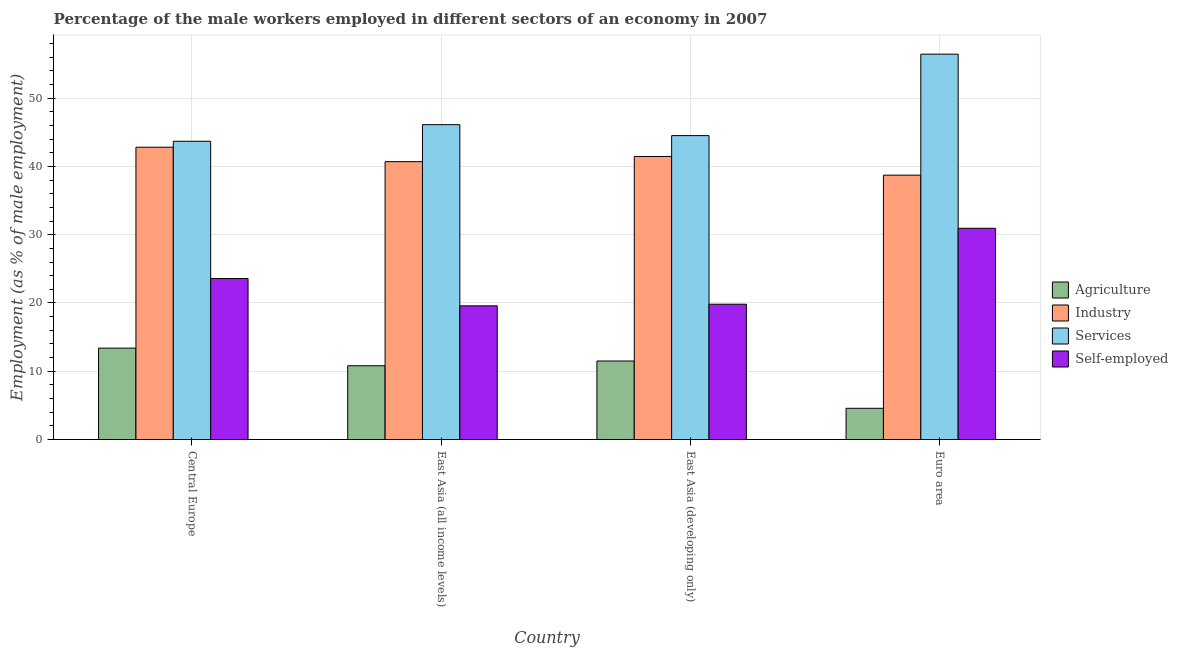How many different coloured bars are there?
Offer a terse response. 4. How many bars are there on the 1st tick from the left?
Ensure brevity in your answer.  4. How many bars are there on the 1st tick from the right?
Provide a short and direct response. 4. What is the label of the 3rd group of bars from the left?
Provide a short and direct response. East Asia (developing only). In how many cases, is the number of bars for a given country not equal to the number of legend labels?
Your response must be concise. 0. What is the percentage of self employed male workers in Central Europe?
Ensure brevity in your answer.  23.58. Across all countries, what is the maximum percentage of male workers in industry?
Keep it short and to the point. 42.82. Across all countries, what is the minimum percentage of self employed male workers?
Offer a terse response. 19.58. In which country was the percentage of male workers in agriculture maximum?
Keep it short and to the point. Central Europe. In which country was the percentage of self employed male workers minimum?
Your response must be concise. East Asia (all income levels). What is the total percentage of male workers in agriculture in the graph?
Offer a very short reply. 40.27. What is the difference between the percentage of self employed male workers in Central Europe and that in East Asia (developing only)?
Your response must be concise. 3.77. What is the difference between the percentage of self employed male workers in Euro area and the percentage of male workers in agriculture in Central Europe?
Your response must be concise. 17.55. What is the average percentage of male workers in agriculture per country?
Keep it short and to the point. 10.07. What is the difference between the percentage of male workers in industry and percentage of male workers in agriculture in Euro area?
Offer a very short reply. 34.15. In how many countries, is the percentage of male workers in services greater than 6 %?
Your answer should be compact. 4. What is the ratio of the percentage of male workers in agriculture in Central Europe to that in East Asia (developing only)?
Provide a short and direct response. 1.16. Is the percentage of male workers in industry in Central Europe less than that in Euro area?
Make the answer very short. No. What is the difference between the highest and the second highest percentage of male workers in industry?
Offer a very short reply. 1.36. What is the difference between the highest and the lowest percentage of male workers in agriculture?
Offer a terse response. 8.82. In how many countries, is the percentage of male workers in industry greater than the average percentage of male workers in industry taken over all countries?
Provide a succinct answer. 2. Is the sum of the percentage of male workers in industry in Central Europe and East Asia (developing only) greater than the maximum percentage of male workers in agriculture across all countries?
Make the answer very short. Yes. What does the 4th bar from the left in Euro area represents?
Your answer should be compact. Self-employed. What does the 1st bar from the right in East Asia (all income levels) represents?
Provide a succinct answer. Self-employed. Is it the case that in every country, the sum of the percentage of male workers in agriculture and percentage of male workers in industry is greater than the percentage of male workers in services?
Provide a short and direct response. No. How many bars are there?
Your response must be concise. 16. Are all the bars in the graph horizontal?
Provide a succinct answer. No. Are the values on the major ticks of Y-axis written in scientific E-notation?
Offer a very short reply. No. Does the graph contain any zero values?
Give a very brief answer. No. Does the graph contain grids?
Give a very brief answer. Yes. Where does the legend appear in the graph?
Your response must be concise. Center right. How many legend labels are there?
Your answer should be compact. 4. How are the legend labels stacked?
Your answer should be compact. Vertical. What is the title of the graph?
Offer a terse response. Percentage of the male workers employed in different sectors of an economy in 2007. What is the label or title of the X-axis?
Your answer should be compact. Country. What is the label or title of the Y-axis?
Provide a succinct answer. Employment (as % of male employment). What is the Employment (as % of male employment) in Agriculture in Central Europe?
Provide a short and direct response. 13.39. What is the Employment (as % of male employment) in Industry in Central Europe?
Your response must be concise. 42.82. What is the Employment (as % of male employment) in Services in Central Europe?
Keep it short and to the point. 43.68. What is the Employment (as % of male employment) of Self-employed in Central Europe?
Your answer should be very brief. 23.58. What is the Employment (as % of male employment) in Agriculture in East Asia (all income levels)?
Offer a terse response. 10.81. What is the Employment (as % of male employment) of Industry in East Asia (all income levels)?
Keep it short and to the point. 40.7. What is the Employment (as % of male employment) of Services in East Asia (all income levels)?
Your response must be concise. 46.12. What is the Employment (as % of male employment) in Self-employed in East Asia (all income levels)?
Make the answer very short. 19.58. What is the Employment (as % of male employment) in Agriculture in East Asia (developing only)?
Give a very brief answer. 11.5. What is the Employment (as % of male employment) of Industry in East Asia (developing only)?
Keep it short and to the point. 41.46. What is the Employment (as % of male employment) of Services in East Asia (developing only)?
Offer a very short reply. 44.51. What is the Employment (as % of male employment) in Self-employed in East Asia (developing only)?
Offer a terse response. 19.82. What is the Employment (as % of male employment) in Agriculture in Euro area?
Keep it short and to the point. 4.57. What is the Employment (as % of male employment) in Industry in Euro area?
Make the answer very short. 38.72. What is the Employment (as % of male employment) of Services in Euro area?
Give a very brief answer. 56.45. What is the Employment (as % of male employment) of Self-employed in Euro area?
Offer a terse response. 30.94. Across all countries, what is the maximum Employment (as % of male employment) in Agriculture?
Provide a succinct answer. 13.39. Across all countries, what is the maximum Employment (as % of male employment) of Industry?
Provide a succinct answer. 42.82. Across all countries, what is the maximum Employment (as % of male employment) in Services?
Keep it short and to the point. 56.45. Across all countries, what is the maximum Employment (as % of male employment) of Self-employed?
Your answer should be very brief. 30.94. Across all countries, what is the minimum Employment (as % of male employment) of Agriculture?
Provide a succinct answer. 4.57. Across all countries, what is the minimum Employment (as % of male employment) in Industry?
Your answer should be compact. 38.72. Across all countries, what is the minimum Employment (as % of male employment) in Services?
Provide a succinct answer. 43.68. Across all countries, what is the minimum Employment (as % of male employment) of Self-employed?
Your response must be concise. 19.58. What is the total Employment (as % of male employment) in Agriculture in the graph?
Make the answer very short. 40.27. What is the total Employment (as % of male employment) of Industry in the graph?
Make the answer very short. 163.69. What is the total Employment (as % of male employment) in Services in the graph?
Make the answer very short. 190.76. What is the total Employment (as % of male employment) in Self-employed in the graph?
Your answer should be compact. 93.92. What is the difference between the Employment (as % of male employment) in Agriculture in Central Europe and that in East Asia (all income levels)?
Your response must be concise. 2.58. What is the difference between the Employment (as % of male employment) of Industry in Central Europe and that in East Asia (all income levels)?
Provide a succinct answer. 2.12. What is the difference between the Employment (as % of male employment) of Services in Central Europe and that in East Asia (all income levels)?
Provide a short and direct response. -2.43. What is the difference between the Employment (as % of male employment) in Self-employed in Central Europe and that in East Asia (all income levels)?
Provide a short and direct response. 4.01. What is the difference between the Employment (as % of male employment) in Agriculture in Central Europe and that in East Asia (developing only)?
Ensure brevity in your answer.  1.89. What is the difference between the Employment (as % of male employment) of Industry in Central Europe and that in East Asia (developing only)?
Offer a very short reply. 1.36. What is the difference between the Employment (as % of male employment) in Services in Central Europe and that in East Asia (developing only)?
Offer a very short reply. -0.83. What is the difference between the Employment (as % of male employment) of Self-employed in Central Europe and that in East Asia (developing only)?
Your answer should be compact. 3.77. What is the difference between the Employment (as % of male employment) of Agriculture in Central Europe and that in Euro area?
Give a very brief answer. 8.82. What is the difference between the Employment (as % of male employment) in Industry in Central Europe and that in Euro area?
Offer a very short reply. 4.09. What is the difference between the Employment (as % of male employment) of Services in Central Europe and that in Euro area?
Give a very brief answer. -12.76. What is the difference between the Employment (as % of male employment) in Self-employed in Central Europe and that in Euro area?
Ensure brevity in your answer.  -7.36. What is the difference between the Employment (as % of male employment) of Agriculture in East Asia (all income levels) and that in East Asia (developing only)?
Make the answer very short. -0.69. What is the difference between the Employment (as % of male employment) in Industry in East Asia (all income levels) and that in East Asia (developing only)?
Your answer should be compact. -0.76. What is the difference between the Employment (as % of male employment) of Services in East Asia (all income levels) and that in East Asia (developing only)?
Your response must be concise. 1.61. What is the difference between the Employment (as % of male employment) of Self-employed in East Asia (all income levels) and that in East Asia (developing only)?
Your answer should be very brief. -0.24. What is the difference between the Employment (as % of male employment) of Agriculture in East Asia (all income levels) and that in Euro area?
Give a very brief answer. 6.24. What is the difference between the Employment (as % of male employment) of Industry in East Asia (all income levels) and that in Euro area?
Keep it short and to the point. 1.98. What is the difference between the Employment (as % of male employment) in Services in East Asia (all income levels) and that in Euro area?
Your response must be concise. -10.33. What is the difference between the Employment (as % of male employment) of Self-employed in East Asia (all income levels) and that in Euro area?
Your answer should be very brief. -11.36. What is the difference between the Employment (as % of male employment) in Agriculture in East Asia (developing only) and that in Euro area?
Provide a succinct answer. 6.93. What is the difference between the Employment (as % of male employment) of Industry in East Asia (developing only) and that in Euro area?
Your answer should be very brief. 2.74. What is the difference between the Employment (as % of male employment) in Services in East Asia (developing only) and that in Euro area?
Offer a terse response. -11.93. What is the difference between the Employment (as % of male employment) of Self-employed in East Asia (developing only) and that in Euro area?
Your answer should be compact. -11.13. What is the difference between the Employment (as % of male employment) of Agriculture in Central Europe and the Employment (as % of male employment) of Industry in East Asia (all income levels)?
Keep it short and to the point. -27.31. What is the difference between the Employment (as % of male employment) of Agriculture in Central Europe and the Employment (as % of male employment) of Services in East Asia (all income levels)?
Offer a very short reply. -32.73. What is the difference between the Employment (as % of male employment) in Agriculture in Central Europe and the Employment (as % of male employment) in Self-employed in East Asia (all income levels)?
Ensure brevity in your answer.  -6.19. What is the difference between the Employment (as % of male employment) in Industry in Central Europe and the Employment (as % of male employment) in Services in East Asia (all income levels)?
Give a very brief answer. -3.3. What is the difference between the Employment (as % of male employment) of Industry in Central Europe and the Employment (as % of male employment) of Self-employed in East Asia (all income levels)?
Provide a succinct answer. 23.24. What is the difference between the Employment (as % of male employment) in Services in Central Europe and the Employment (as % of male employment) in Self-employed in East Asia (all income levels)?
Make the answer very short. 24.11. What is the difference between the Employment (as % of male employment) in Agriculture in Central Europe and the Employment (as % of male employment) in Industry in East Asia (developing only)?
Make the answer very short. -28.07. What is the difference between the Employment (as % of male employment) in Agriculture in Central Europe and the Employment (as % of male employment) in Services in East Asia (developing only)?
Keep it short and to the point. -31.12. What is the difference between the Employment (as % of male employment) in Agriculture in Central Europe and the Employment (as % of male employment) in Self-employed in East Asia (developing only)?
Offer a very short reply. -6.43. What is the difference between the Employment (as % of male employment) of Industry in Central Europe and the Employment (as % of male employment) of Services in East Asia (developing only)?
Ensure brevity in your answer.  -1.7. What is the difference between the Employment (as % of male employment) of Industry in Central Europe and the Employment (as % of male employment) of Self-employed in East Asia (developing only)?
Provide a succinct answer. 23. What is the difference between the Employment (as % of male employment) of Services in Central Europe and the Employment (as % of male employment) of Self-employed in East Asia (developing only)?
Provide a succinct answer. 23.87. What is the difference between the Employment (as % of male employment) of Agriculture in Central Europe and the Employment (as % of male employment) of Industry in Euro area?
Offer a very short reply. -25.33. What is the difference between the Employment (as % of male employment) in Agriculture in Central Europe and the Employment (as % of male employment) in Services in Euro area?
Give a very brief answer. -43.06. What is the difference between the Employment (as % of male employment) in Agriculture in Central Europe and the Employment (as % of male employment) in Self-employed in Euro area?
Provide a succinct answer. -17.55. What is the difference between the Employment (as % of male employment) in Industry in Central Europe and the Employment (as % of male employment) in Services in Euro area?
Provide a short and direct response. -13.63. What is the difference between the Employment (as % of male employment) of Industry in Central Europe and the Employment (as % of male employment) of Self-employed in Euro area?
Offer a very short reply. 11.87. What is the difference between the Employment (as % of male employment) of Services in Central Europe and the Employment (as % of male employment) of Self-employed in Euro area?
Provide a short and direct response. 12.74. What is the difference between the Employment (as % of male employment) in Agriculture in East Asia (all income levels) and the Employment (as % of male employment) in Industry in East Asia (developing only)?
Offer a terse response. -30.65. What is the difference between the Employment (as % of male employment) in Agriculture in East Asia (all income levels) and the Employment (as % of male employment) in Services in East Asia (developing only)?
Ensure brevity in your answer.  -33.7. What is the difference between the Employment (as % of male employment) of Agriculture in East Asia (all income levels) and the Employment (as % of male employment) of Self-employed in East Asia (developing only)?
Offer a terse response. -9.01. What is the difference between the Employment (as % of male employment) of Industry in East Asia (all income levels) and the Employment (as % of male employment) of Services in East Asia (developing only)?
Offer a terse response. -3.82. What is the difference between the Employment (as % of male employment) in Industry in East Asia (all income levels) and the Employment (as % of male employment) in Self-employed in East Asia (developing only)?
Offer a very short reply. 20.88. What is the difference between the Employment (as % of male employment) in Services in East Asia (all income levels) and the Employment (as % of male employment) in Self-employed in East Asia (developing only)?
Your answer should be very brief. 26.3. What is the difference between the Employment (as % of male employment) of Agriculture in East Asia (all income levels) and the Employment (as % of male employment) of Industry in Euro area?
Your answer should be compact. -27.91. What is the difference between the Employment (as % of male employment) of Agriculture in East Asia (all income levels) and the Employment (as % of male employment) of Services in Euro area?
Make the answer very short. -45.64. What is the difference between the Employment (as % of male employment) in Agriculture in East Asia (all income levels) and the Employment (as % of male employment) in Self-employed in Euro area?
Offer a very short reply. -20.13. What is the difference between the Employment (as % of male employment) in Industry in East Asia (all income levels) and the Employment (as % of male employment) in Services in Euro area?
Ensure brevity in your answer.  -15.75. What is the difference between the Employment (as % of male employment) in Industry in East Asia (all income levels) and the Employment (as % of male employment) in Self-employed in Euro area?
Ensure brevity in your answer.  9.76. What is the difference between the Employment (as % of male employment) of Services in East Asia (all income levels) and the Employment (as % of male employment) of Self-employed in Euro area?
Your response must be concise. 15.18. What is the difference between the Employment (as % of male employment) of Agriculture in East Asia (developing only) and the Employment (as % of male employment) of Industry in Euro area?
Provide a succinct answer. -27.22. What is the difference between the Employment (as % of male employment) in Agriculture in East Asia (developing only) and the Employment (as % of male employment) in Services in Euro area?
Keep it short and to the point. -44.94. What is the difference between the Employment (as % of male employment) of Agriculture in East Asia (developing only) and the Employment (as % of male employment) of Self-employed in Euro area?
Your answer should be very brief. -19.44. What is the difference between the Employment (as % of male employment) in Industry in East Asia (developing only) and the Employment (as % of male employment) in Services in Euro area?
Your answer should be very brief. -14.99. What is the difference between the Employment (as % of male employment) in Industry in East Asia (developing only) and the Employment (as % of male employment) in Self-employed in Euro area?
Provide a succinct answer. 10.52. What is the difference between the Employment (as % of male employment) of Services in East Asia (developing only) and the Employment (as % of male employment) of Self-employed in Euro area?
Your response must be concise. 13.57. What is the average Employment (as % of male employment) in Agriculture per country?
Offer a very short reply. 10.07. What is the average Employment (as % of male employment) of Industry per country?
Provide a short and direct response. 40.92. What is the average Employment (as % of male employment) of Services per country?
Ensure brevity in your answer.  47.69. What is the average Employment (as % of male employment) in Self-employed per country?
Ensure brevity in your answer.  23.48. What is the difference between the Employment (as % of male employment) in Agriculture and Employment (as % of male employment) in Industry in Central Europe?
Provide a succinct answer. -29.43. What is the difference between the Employment (as % of male employment) of Agriculture and Employment (as % of male employment) of Services in Central Europe?
Offer a terse response. -30.3. What is the difference between the Employment (as % of male employment) in Agriculture and Employment (as % of male employment) in Self-employed in Central Europe?
Offer a terse response. -10.2. What is the difference between the Employment (as % of male employment) in Industry and Employment (as % of male employment) in Services in Central Europe?
Offer a terse response. -0.87. What is the difference between the Employment (as % of male employment) of Industry and Employment (as % of male employment) of Self-employed in Central Europe?
Make the answer very short. 19.23. What is the difference between the Employment (as % of male employment) in Services and Employment (as % of male employment) in Self-employed in Central Europe?
Provide a short and direct response. 20.1. What is the difference between the Employment (as % of male employment) in Agriculture and Employment (as % of male employment) in Industry in East Asia (all income levels)?
Offer a terse response. -29.89. What is the difference between the Employment (as % of male employment) of Agriculture and Employment (as % of male employment) of Services in East Asia (all income levels)?
Keep it short and to the point. -35.31. What is the difference between the Employment (as % of male employment) of Agriculture and Employment (as % of male employment) of Self-employed in East Asia (all income levels)?
Your answer should be compact. -8.77. What is the difference between the Employment (as % of male employment) in Industry and Employment (as % of male employment) in Services in East Asia (all income levels)?
Provide a short and direct response. -5.42. What is the difference between the Employment (as % of male employment) in Industry and Employment (as % of male employment) in Self-employed in East Asia (all income levels)?
Your response must be concise. 21.12. What is the difference between the Employment (as % of male employment) of Services and Employment (as % of male employment) of Self-employed in East Asia (all income levels)?
Make the answer very short. 26.54. What is the difference between the Employment (as % of male employment) in Agriculture and Employment (as % of male employment) in Industry in East Asia (developing only)?
Offer a terse response. -29.96. What is the difference between the Employment (as % of male employment) of Agriculture and Employment (as % of male employment) of Services in East Asia (developing only)?
Give a very brief answer. -33.01. What is the difference between the Employment (as % of male employment) of Agriculture and Employment (as % of male employment) of Self-employed in East Asia (developing only)?
Offer a terse response. -8.31. What is the difference between the Employment (as % of male employment) in Industry and Employment (as % of male employment) in Services in East Asia (developing only)?
Offer a terse response. -3.05. What is the difference between the Employment (as % of male employment) of Industry and Employment (as % of male employment) of Self-employed in East Asia (developing only)?
Offer a terse response. 21.64. What is the difference between the Employment (as % of male employment) in Services and Employment (as % of male employment) in Self-employed in East Asia (developing only)?
Provide a short and direct response. 24.7. What is the difference between the Employment (as % of male employment) in Agriculture and Employment (as % of male employment) in Industry in Euro area?
Offer a very short reply. -34.15. What is the difference between the Employment (as % of male employment) in Agriculture and Employment (as % of male employment) in Services in Euro area?
Your answer should be compact. -51.88. What is the difference between the Employment (as % of male employment) in Agriculture and Employment (as % of male employment) in Self-employed in Euro area?
Offer a very short reply. -26.37. What is the difference between the Employment (as % of male employment) of Industry and Employment (as % of male employment) of Services in Euro area?
Offer a very short reply. -17.72. What is the difference between the Employment (as % of male employment) in Industry and Employment (as % of male employment) in Self-employed in Euro area?
Give a very brief answer. 7.78. What is the difference between the Employment (as % of male employment) in Services and Employment (as % of male employment) in Self-employed in Euro area?
Provide a short and direct response. 25.51. What is the ratio of the Employment (as % of male employment) in Agriculture in Central Europe to that in East Asia (all income levels)?
Ensure brevity in your answer.  1.24. What is the ratio of the Employment (as % of male employment) of Industry in Central Europe to that in East Asia (all income levels)?
Give a very brief answer. 1.05. What is the ratio of the Employment (as % of male employment) of Services in Central Europe to that in East Asia (all income levels)?
Ensure brevity in your answer.  0.95. What is the ratio of the Employment (as % of male employment) in Self-employed in Central Europe to that in East Asia (all income levels)?
Your answer should be very brief. 1.2. What is the ratio of the Employment (as % of male employment) of Agriculture in Central Europe to that in East Asia (developing only)?
Make the answer very short. 1.16. What is the ratio of the Employment (as % of male employment) in Industry in Central Europe to that in East Asia (developing only)?
Give a very brief answer. 1.03. What is the ratio of the Employment (as % of male employment) in Services in Central Europe to that in East Asia (developing only)?
Ensure brevity in your answer.  0.98. What is the ratio of the Employment (as % of male employment) in Self-employed in Central Europe to that in East Asia (developing only)?
Give a very brief answer. 1.19. What is the ratio of the Employment (as % of male employment) of Agriculture in Central Europe to that in Euro area?
Provide a succinct answer. 2.93. What is the ratio of the Employment (as % of male employment) in Industry in Central Europe to that in Euro area?
Your response must be concise. 1.11. What is the ratio of the Employment (as % of male employment) in Services in Central Europe to that in Euro area?
Provide a short and direct response. 0.77. What is the ratio of the Employment (as % of male employment) of Self-employed in Central Europe to that in Euro area?
Ensure brevity in your answer.  0.76. What is the ratio of the Employment (as % of male employment) in Agriculture in East Asia (all income levels) to that in East Asia (developing only)?
Ensure brevity in your answer.  0.94. What is the ratio of the Employment (as % of male employment) of Industry in East Asia (all income levels) to that in East Asia (developing only)?
Your response must be concise. 0.98. What is the ratio of the Employment (as % of male employment) of Services in East Asia (all income levels) to that in East Asia (developing only)?
Keep it short and to the point. 1.04. What is the ratio of the Employment (as % of male employment) in Self-employed in East Asia (all income levels) to that in East Asia (developing only)?
Make the answer very short. 0.99. What is the ratio of the Employment (as % of male employment) in Agriculture in East Asia (all income levels) to that in Euro area?
Provide a succinct answer. 2.36. What is the ratio of the Employment (as % of male employment) in Industry in East Asia (all income levels) to that in Euro area?
Make the answer very short. 1.05. What is the ratio of the Employment (as % of male employment) in Services in East Asia (all income levels) to that in Euro area?
Make the answer very short. 0.82. What is the ratio of the Employment (as % of male employment) of Self-employed in East Asia (all income levels) to that in Euro area?
Your response must be concise. 0.63. What is the ratio of the Employment (as % of male employment) of Agriculture in East Asia (developing only) to that in Euro area?
Offer a terse response. 2.52. What is the ratio of the Employment (as % of male employment) of Industry in East Asia (developing only) to that in Euro area?
Offer a very short reply. 1.07. What is the ratio of the Employment (as % of male employment) of Services in East Asia (developing only) to that in Euro area?
Keep it short and to the point. 0.79. What is the ratio of the Employment (as % of male employment) in Self-employed in East Asia (developing only) to that in Euro area?
Your response must be concise. 0.64. What is the difference between the highest and the second highest Employment (as % of male employment) of Agriculture?
Your answer should be very brief. 1.89. What is the difference between the highest and the second highest Employment (as % of male employment) in Industry?
Your response must be concise. 1.36. What is the difference between the highest and the second highest Employment (as % of male employment) of Services?
Provide a succinct answer. 10.33. What is the difference between the highest and the second highest Employment (as % of male employment) in Self-employed?
Your answer should be very brief. 7.36. What is the difference between the highest and the lowest Employment (as % of male employment) of Agriculture?
Your answer should be compact. 8.82. What is the difference between the highest and the lowest Employment (as % of male employment) in Industry?
Ensure brevity in your answer.  4.09. What is the difference between the highest and the lowest Employment (as % of male employment) in Services?
Your answer should be very brief. 12.76. What is the difference between the highest and the lowest Employment (as % of male employment) of Self-employed?
Your answer should be compact. 11.36. 